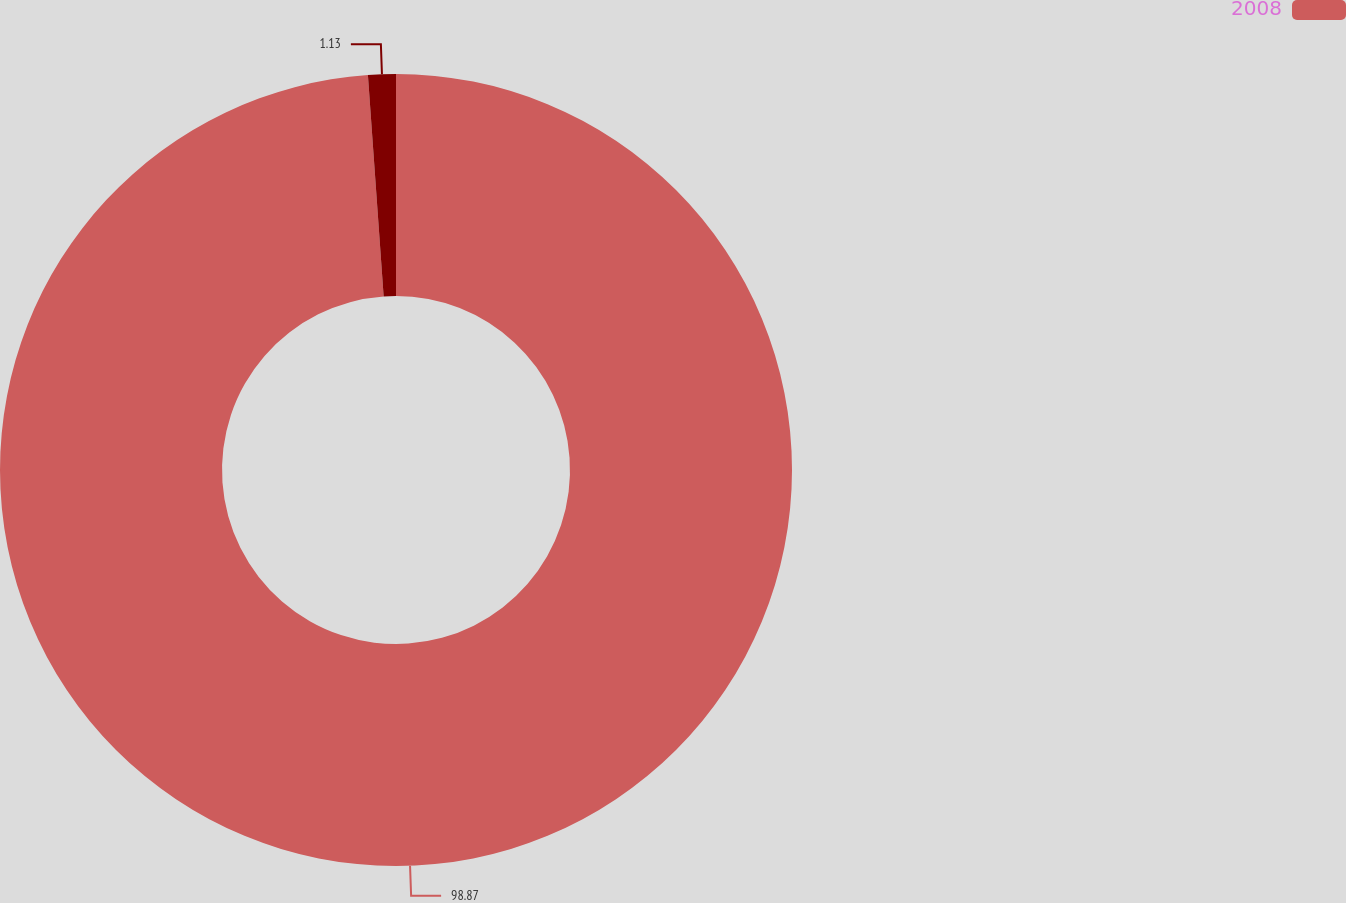Convert chart to OTSL. <chart><loc_0><loc_0><loc_500><loc_500><pie_chart><fcel>2008<fcel>Unnamed: 1<nl><fcel>98.87%<fcel>1.13%<nl></chart> 